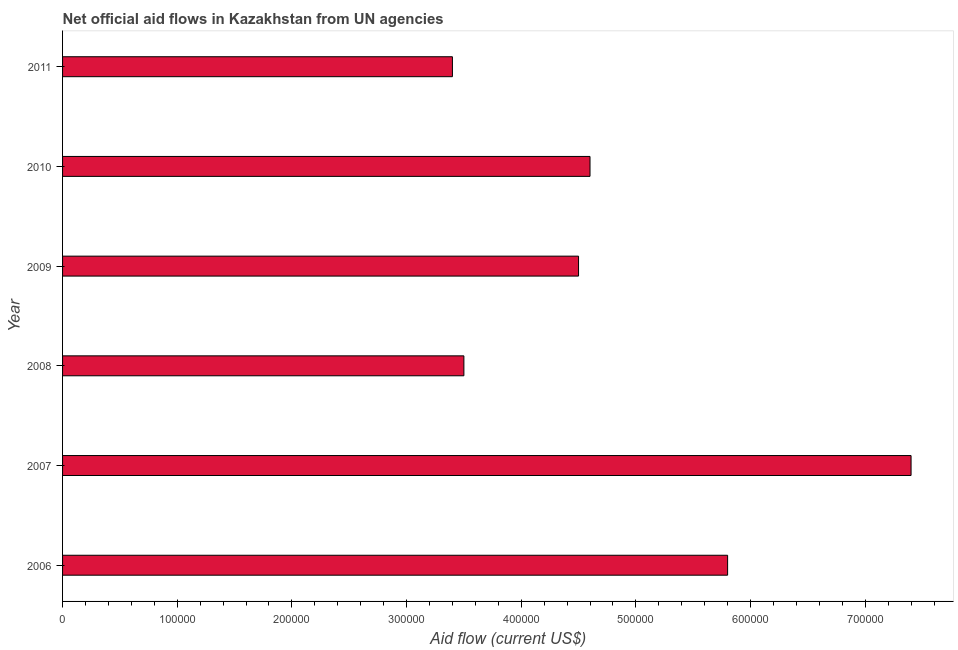Does the graph contain grids?
Make the answer very short. No. What is the title of the graph?
Offer a very short reply. Net official aid flows in Kazakhstan from UN agencies. What is the label or title of the X-axis?
Give a very brief answer. Aid flow (current US$). What is the label or title of the Y-axis?
Keep it short and to the point. Year. What is the net official flows from un agencies in 2010?
Your response must be concise. 4.60e+05. Across all years, what is the maximum net official flows from un agencies?
Your answer should be compact. 7.40e+05. Across all years, what is the minimum net official flows from un agencies?
Provide a succinct answer. 3.40e+05. What is the sum of the net official flows from un agencies?
Give a very brief answer. 2.92e+06. What is the difference between the net official flows from un agencies in 2006 and 2007?
Offer a terse response. -1.60e+05. What is the average net official flows from un agencies per year?
Your answer should be compact. 4.87e+05. What is the median net official flows from un agencies?
Your answer should be very brief. 4.55e+05. In how many years, is the net official flows from un agencies greater than 480000 US$?
Offer a terse response. 2. Do a majority of the years between 2006 and 2011 (inclusive) have net official flows from un agencies greater than 640000 US$?
Your answer should be compact. No. What is the ratio of the net official flows from un agencies in 2010 to that in 2011?
Provide a short and direct response. 1.35. Is the net official flows from un agencies in 2009 less than that in 2010?
Provide a short and direct response. Yes. Is the difference between the net official flows from un agencies in 2008 and 2011 greater than the difference between any two years?
Your response must be concise. No. What is the difference between the highest and the second highest net official flows from un agencies?
Make the answer very short. 1.60e+05. What is the difference between the highest and the lowest net official flows from un agencies?
Give a very brief answer. 4.00e+05. In how many years, is the net official flows from un agencies greater than the average net official flows from un agencies taken over all years?
Provide a short and direct response. 2. How many bars are there?
Your answer should be compact. 6. What is the difference between two consecutive major ticks on the X-axis?
Provide a short and direct response. 1.00e+05. Are the values on the major ticks of X-axis written in scientific E-notation?
Make the answer very short. No. What is the Aid flow (current US$) of 2006?
Offer a very short reply. 5.80e+05. What is the Aid flow (current US$) in 2007?
Ensure brevity in your answer.  7.40e+05. What is the Aid flow (current US$) in 2011?
Offer a terse response. 3.40e+05. What is the difference between the Aid flow (current US$) in 2006 and 2007?
Offer a terse response. -1.60e+05. What is the difference between the Aid flow (current US$) in 2006 and 2011?
Provide a short and direct response. 2.40e+05. What is the difference between the Aid flow (current US$) in 2007 and 2010?
Your answer should be compact. 2.80e+05. What is the difference between the Aid flow (current US$) in 2007 and 2011?
Your response must be concise. 4.00e+05. What is the difference between the Aid flow (current US$) in 2008 and 2009?
Offer a very short reply. -1.00e+05. What is the difference between the Aid flow (current US$) in 2009 and 2011?
Offer a very short reply. 1.10e+05. What is the difference between the Aid flow (current US$) in 2010 and 2011?
Offer a very short reply. 1.20e+05. What is the ratio of the Aid flow (current US$) in 2006 to that in 2007?
Make the answer very short. 0.78. What is the ratio of the Aid flow (current US$) in 2006 to that in 2008?
Keep it short and to the point. 1.66. What is the ratio of the Aid flow (current US$) in 2006 to that in 2009?
Ensure brevity in your answer.  1.29. What is the ratio of the Aid flow (current US$) in 2006 to that in 2010?
Offer a terse response. 1.26. What is the ratio of the Aid flow (current US$) in 2006 to that in 2011?
Provide a succinct answer. 1.71. What is the ratio of the Aid flow (current US$) in 2007 to that in 2008?
Offer a terse response. 2.11. What is the ratio of the Aid flow (current US$) in 2007 to that in 2009?
Give a very brief answer. 1.64. What is the ratio of the Aid flow (current US$) in 2007 to that in 2010?
Provide a short and direct response. 1.61. What is the ratio of the Aid flow (current US$) in 2007 to that in 2011?
Offer a terse response. 2.18. What is the ratio of the Aid flow (current US$) in 2008 to that in 2009?
Your response must be concise. 0.78. What is the ratio of the Aid flow (current US$) in 2008 to that in 2010?
Provide a succinct answer. 0.76. What is the ratio of the Aid flow (current US$) in 2009 to that in 2011?
Offer a very short reply. 1.32. What is the ratio of the Aid flow (current US$) in 2010 to that in 2011?
Ensure brevity in your answer.  1.35. 